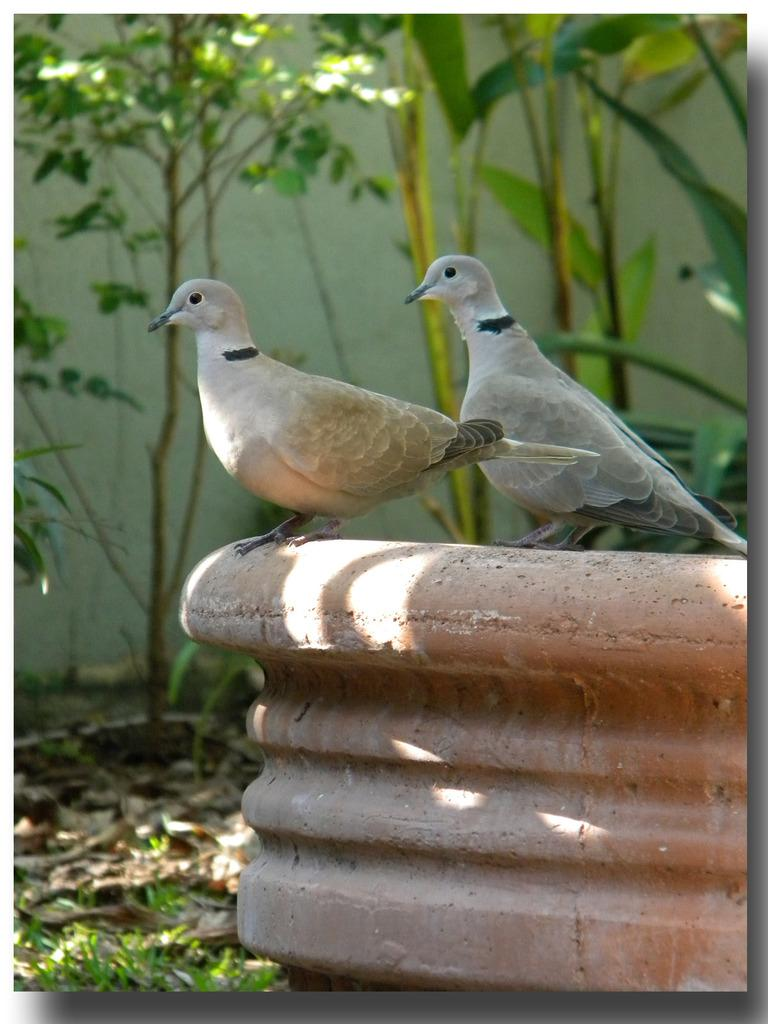How many birds are present in the image? There are two birds in the image. What can be seen in the background of the image? There is grass, trees, and a wall in the background of the image. What level of advice can be obtained from the tree in the image? There is no tree in the image that could provide advice. 